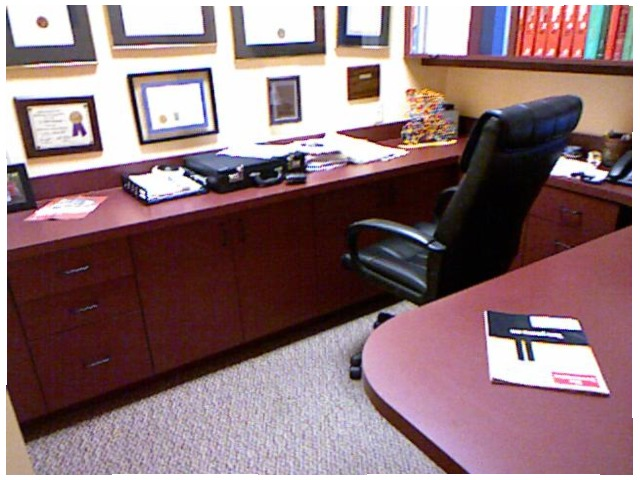<image>
Is the chair on the desk? No. The chair is not positioned on the desk. They may be near each other, but the chair is not supported by or resting on top of the desk. Where is the plaque in relation to the wall? Is it on the wall? No. The plaque is not positioned on the wall. They may be near each other, but the plaque is not supported by or resting on top of the wall. Where is the photoframe in relation to the briefcase? Is it above the briefcase? Yes. The photoframe is positioned above the briefcase in the vertical space, higher up in the scene. Is the briefcase to the right of the paper tray? No. The briefcase is not to the right of the paper tray. The horizontal positioning shows a different relationship. Is there a chair next to the desk? Yes. The chair is positioned adjacent to the desk, located nearby in the same general area. 